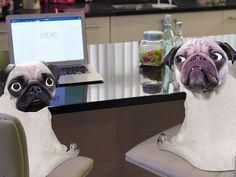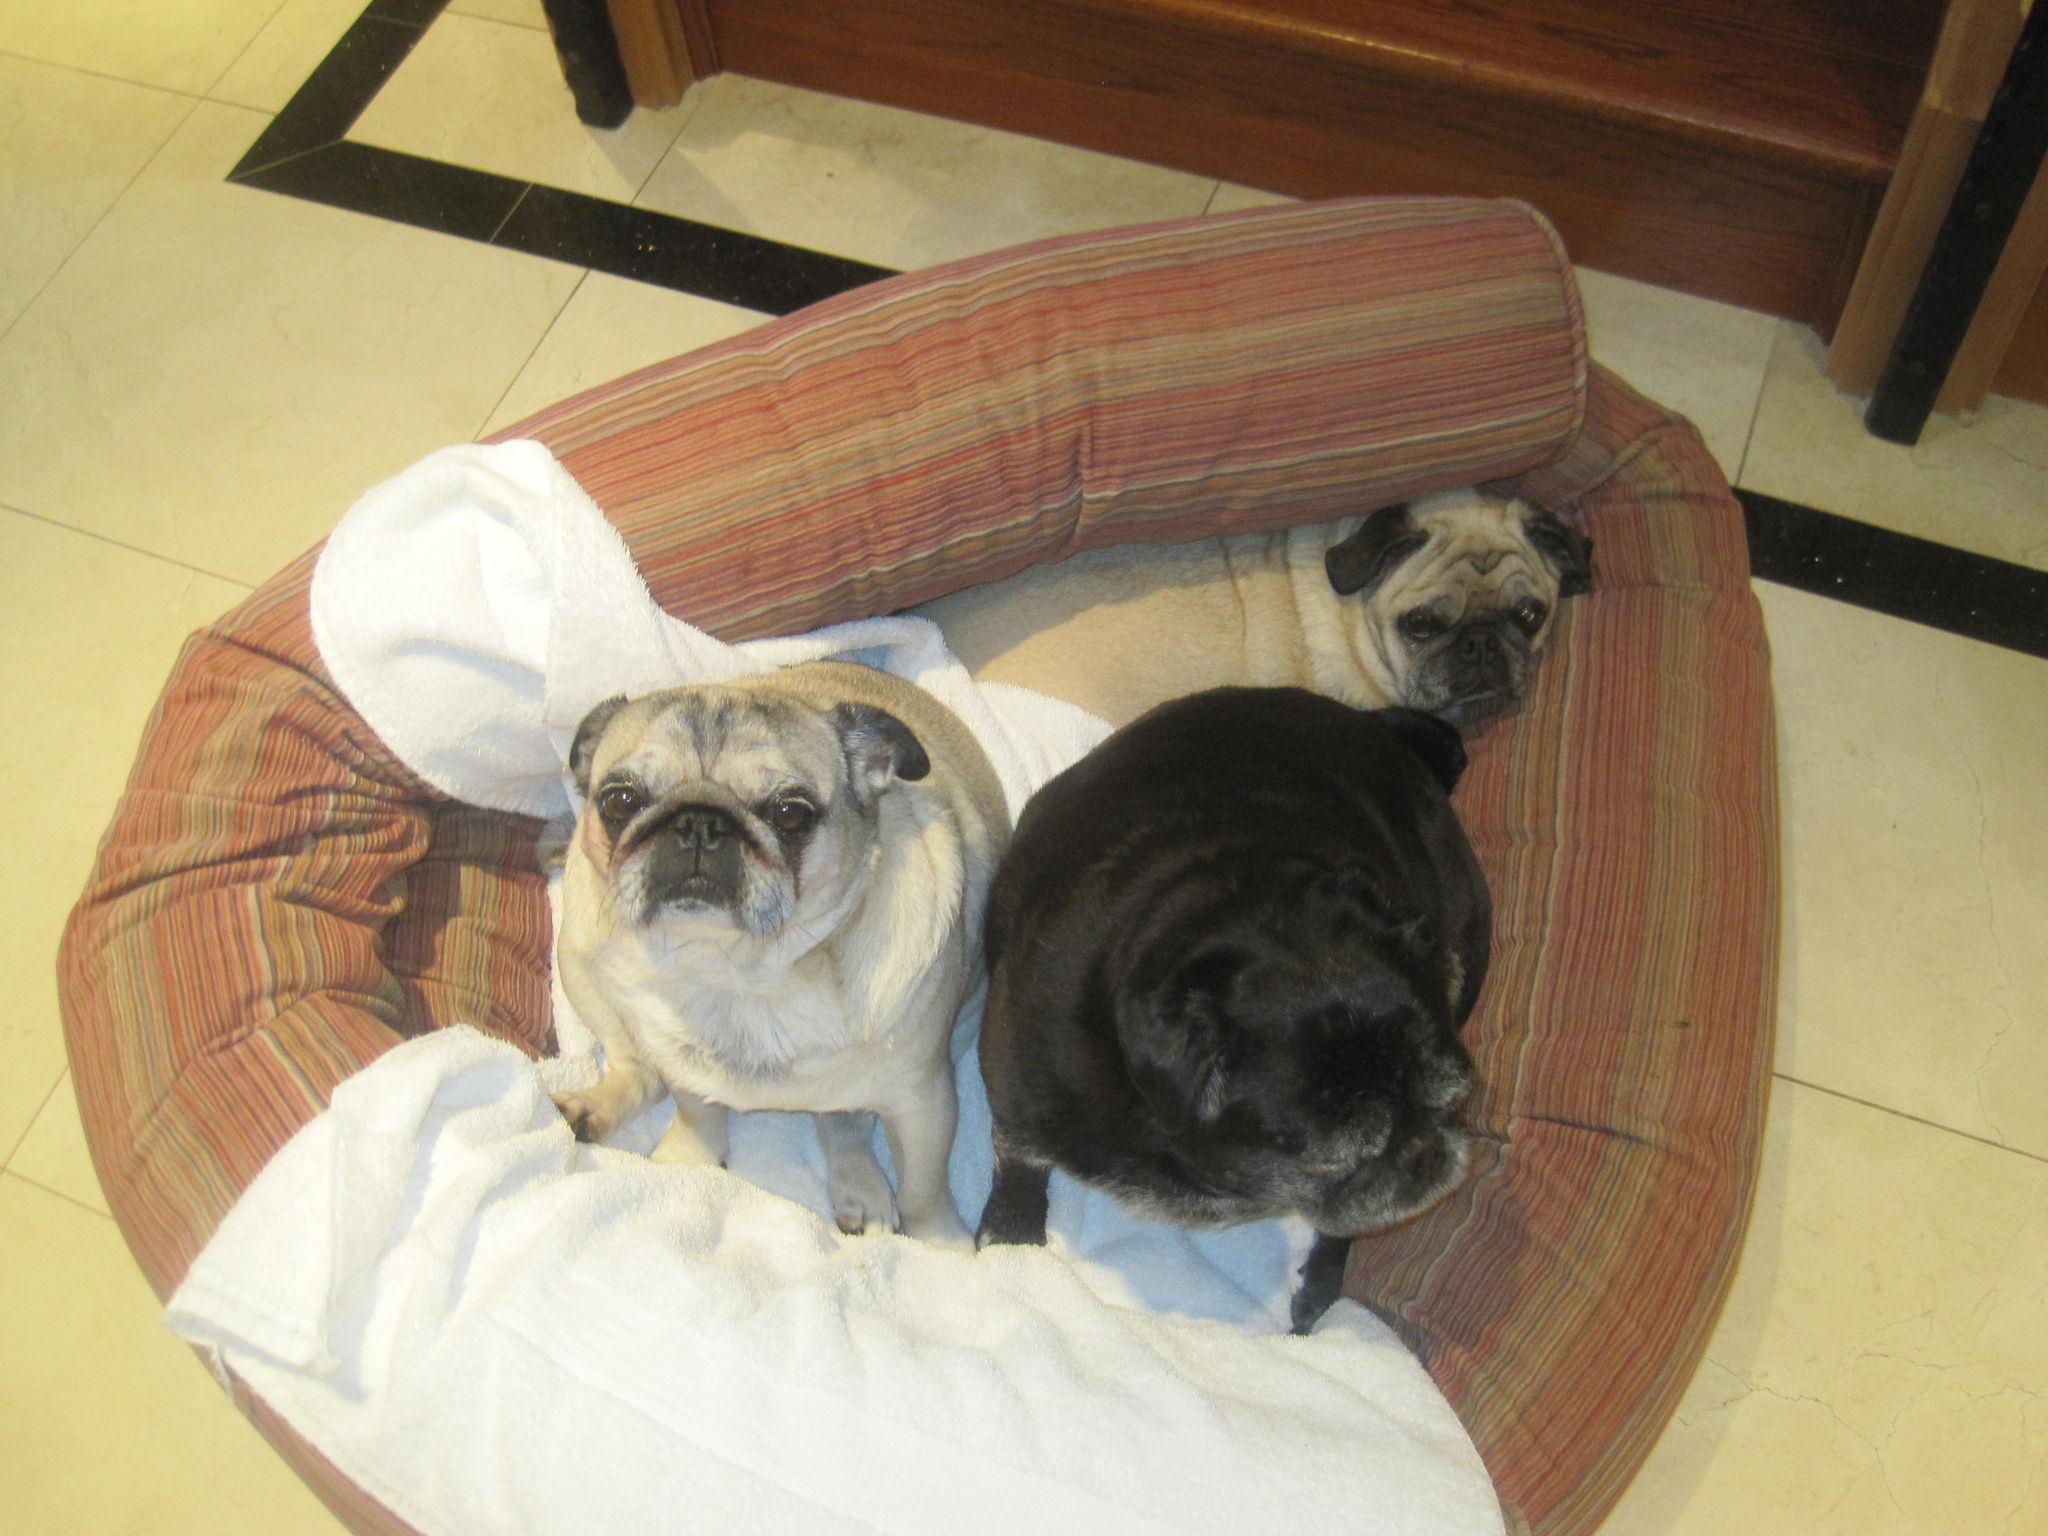The first image is the image on the left, the second image is the image on the right. For the images shown, is this caption "In at least one image there are three pugs sharing one dog bed." true? Answer yes or no. Yes. The first image is the image on the left, the second image is the image on the right. Evaluate the accuracy of this statement regarding the images: "All dogs shown are buff-beige pugs with darker muzzles, and one image contains three pugs sitting upright, while the other image contains at least two pugs on a type of bed.". Is it true? Answer yes or no. No. 